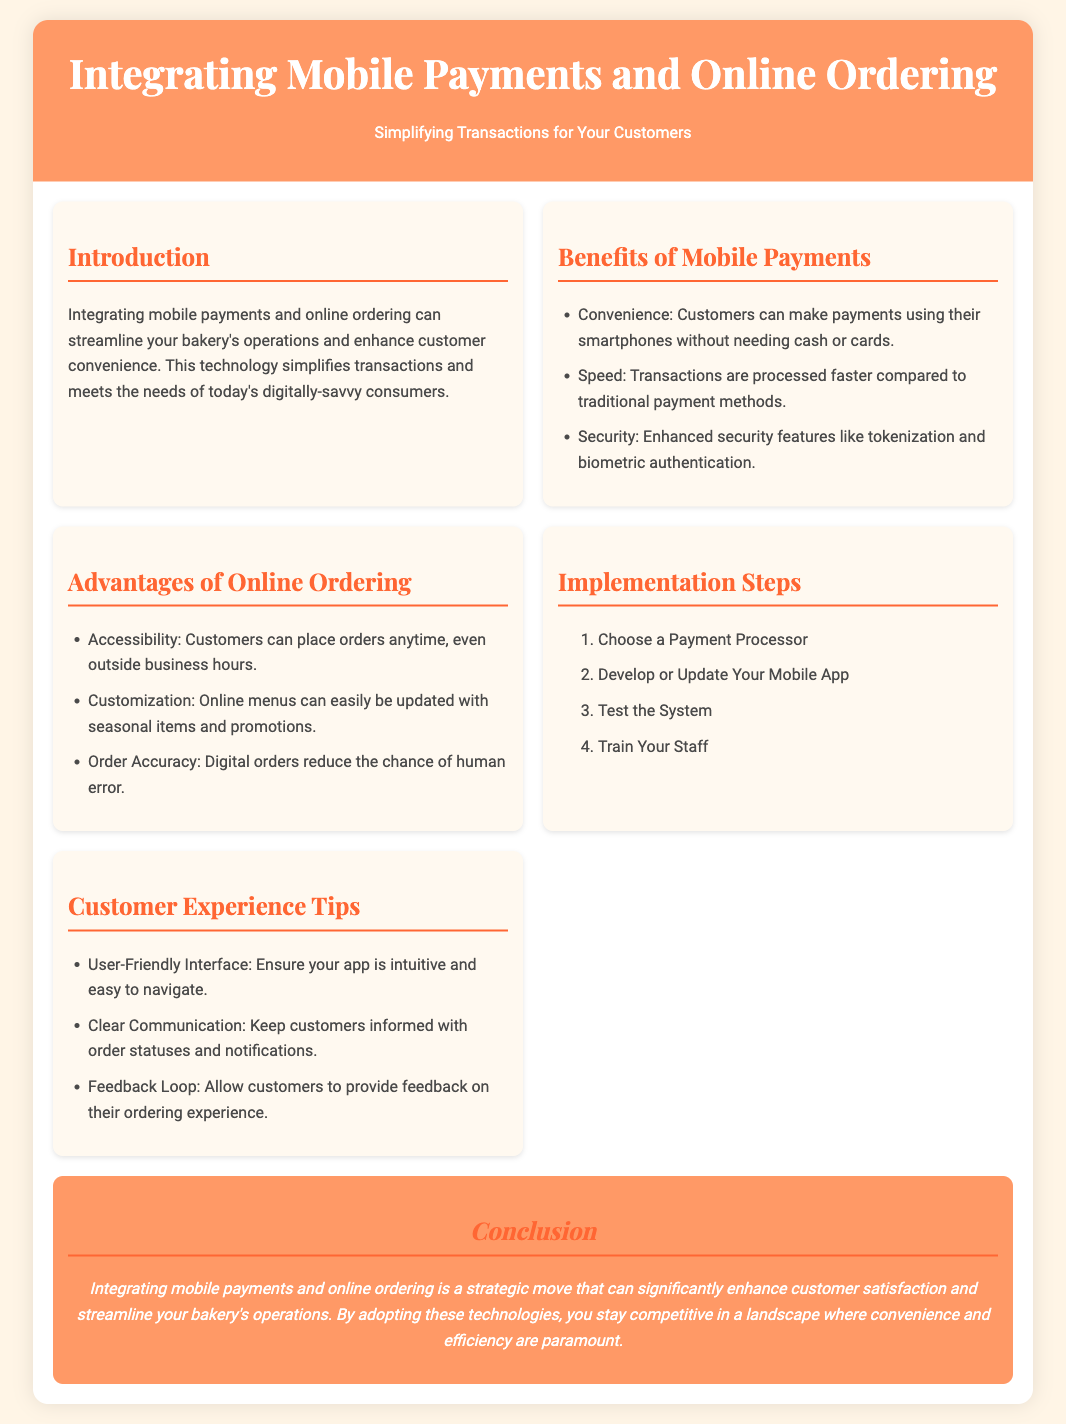what is the title of the presentation? The title of the presentation is prominently displayed at the top of the document.
Answer: Integrating Mobile Payments and Online Ordering what is one benefit of mobile payments? The document lists several benefits of mobile payments in a bullet point format.
Answer: Convenience what is the first implementation step mentioned? The steps for implementation are presented in a numbered list, where the first step is specifically highlighted.
Answer: Choose a Payment Processor how does online ordering improve order accuracy? The document explains that digital orders help in reducing the chances of mistakes.
Answer: Digital orders reduce the chance of human error what is a tip for customer experience? The tips for enhancing customer experience are presented in a bullet list format, providing insights on user interaction.
Answer: User-Friendly Interface what aspect of online ordering addresses customer convenience? One of the advantages listed helps explain how customers benefit in terms of access to placing orders.
Answer: Accessibility how does integrating mobile payments and online ordering affect customer satisfaction? The conclusion summarizes the overall impact of implementation on customer experience and operational efficiency.
Answer: Significantly enhance customer satisfaction 